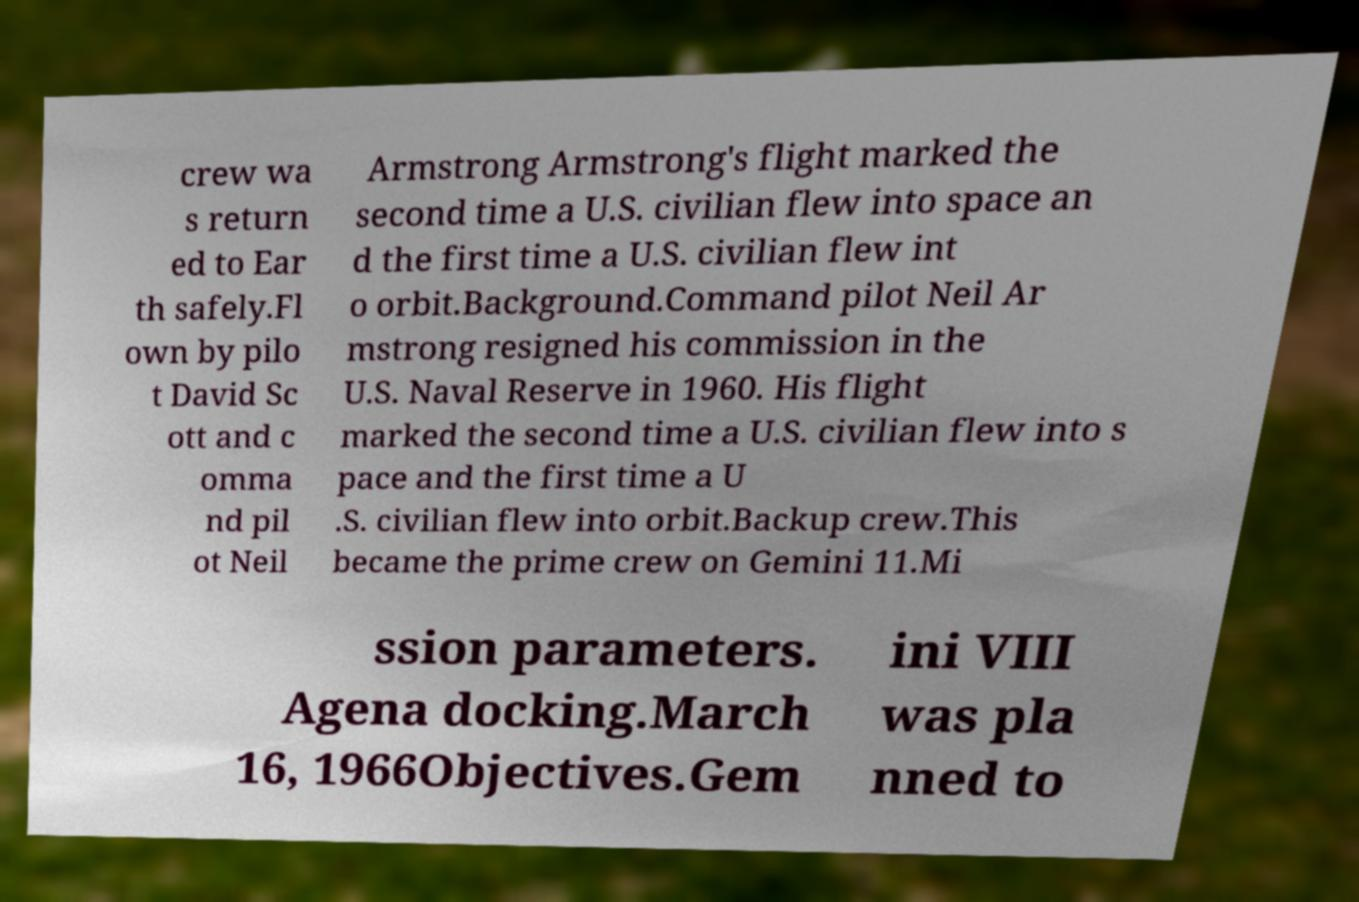I need the written content from this picture converted into text. Can you do that? crew wa s return ed to Ear th safely.Fl own by pilo t David Sc ott and c omma nd pil ot Neil Armstrong Armstrong's flight marked the second time a U.S. civilian flew into space an d the first time a U.S. civilian flew int o orbit.Background.Command pilot Neil Ar mstrong resigned his commission in the U.S. Naval Reserve in 1960. His flight marked the second time a U.S. civilian flew into s pace and the first time a U .S. civilian flew into orbit.Backup crew.This became the prime crew on Gemini 11.Mi ssion parameters. Agena docking.March 16, 1966Objectives.Gem ini VIII was pla nned to 